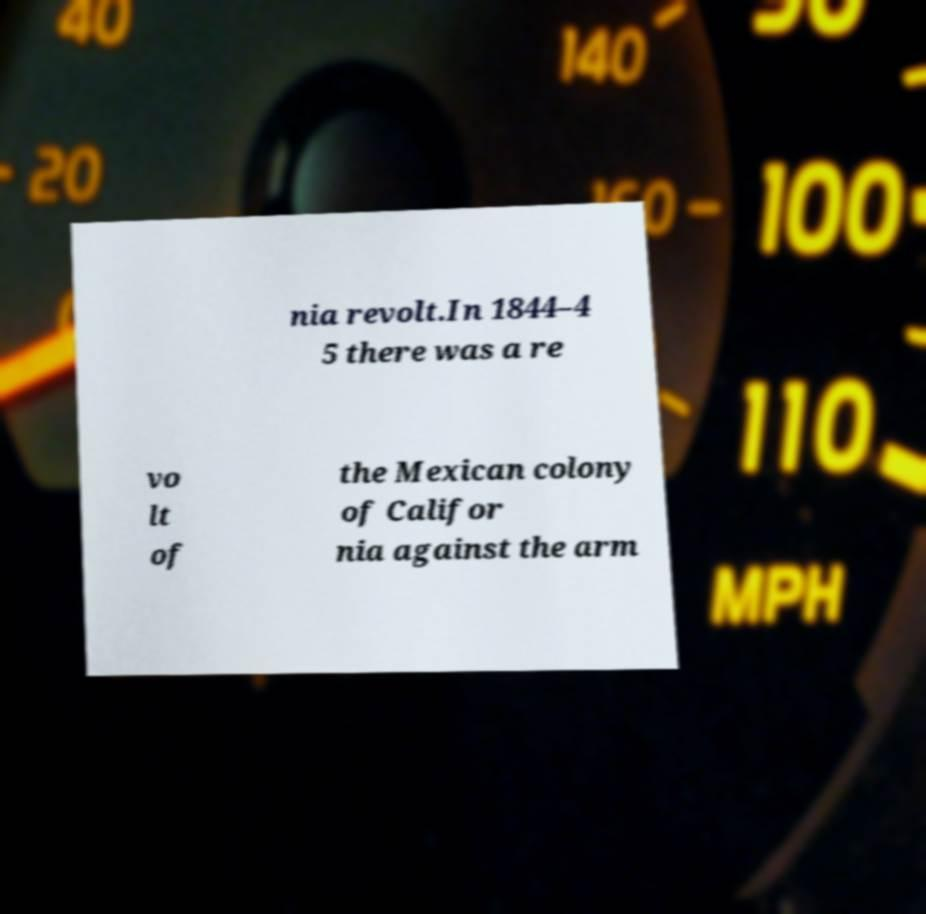Please identify and transcribe the text found in this image. nia revolt.In 1844–4 5 there was a re vo lt of the Mexican colony of Califor nia against the arm 